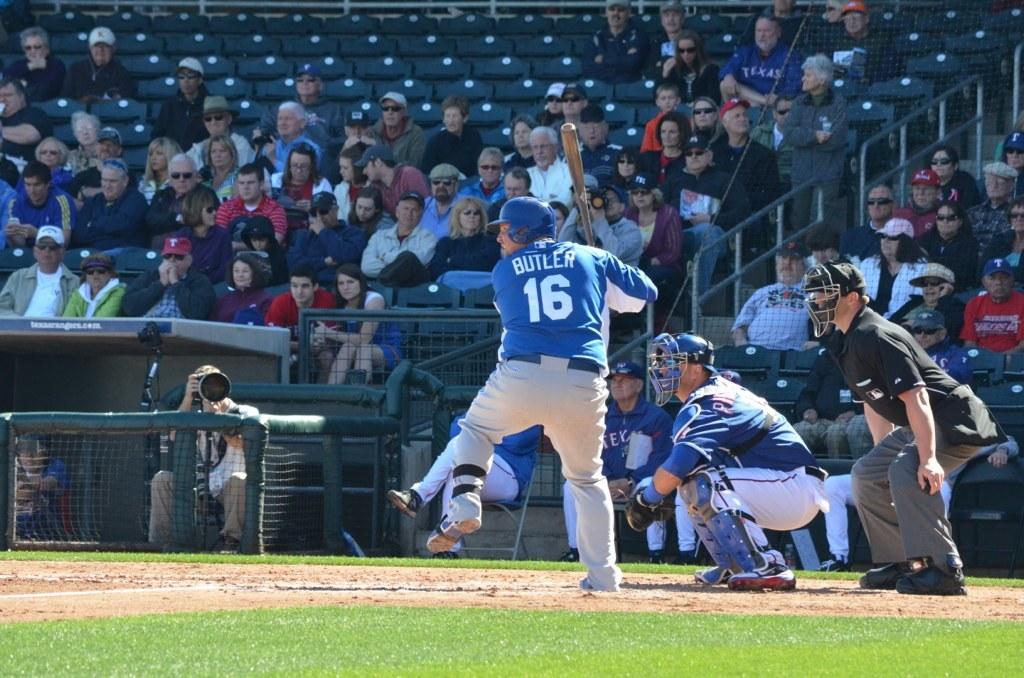What number is on the back of the baseball players jersey?
Ensure brevity in your answer.  16. What is the players name who is at bat?
Ensure brevity in your answer.  Butler. 